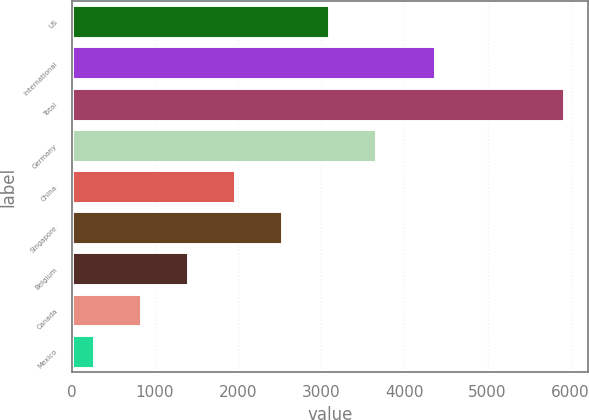<chart> <loc_0><loc_0><loc_500><loc_500><bar_chart><fcel>US<fcel>International<fcel>Total<fcel>Germany<fcel>China<fcel>Singapore<fcel>Belgium<fcel>Canada<fcel>Mexico<nl><fcel>3092.5<fcel>4363<fcel>5918<fcel>3657.6<fcel>1962.3<fcel>2527.4<fcel>1397.2<fcel>832.1<fcel>267<nl></chart> 